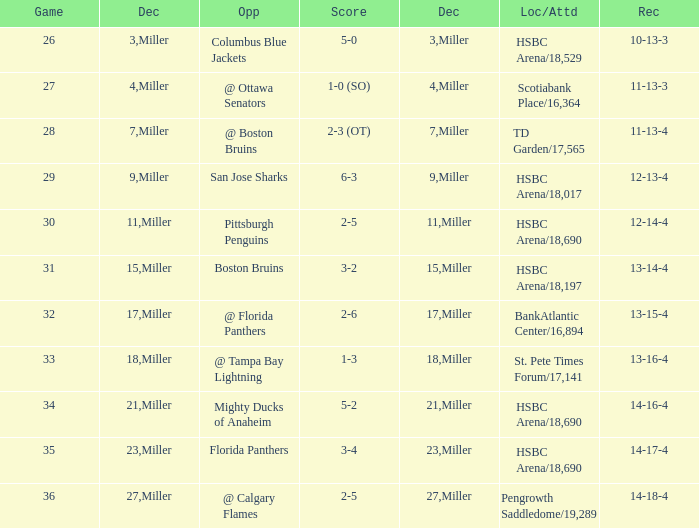Name the number of game 2-6 1.0. 